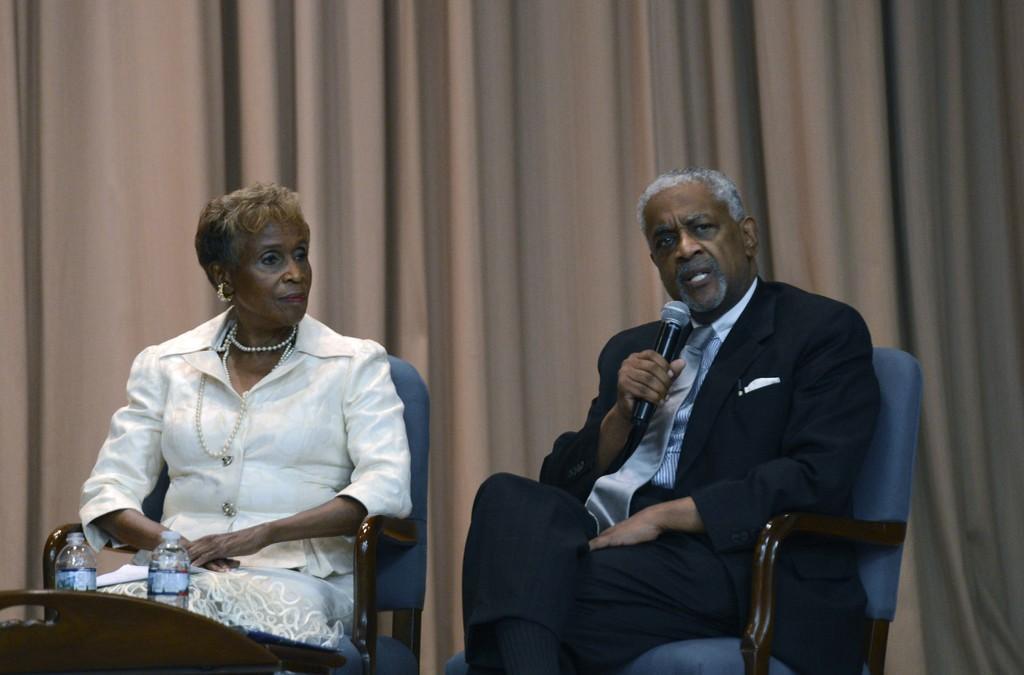Can you describe this image briefly? There are two people in image man and woman siting on chair. On right side there is a man sitting on chair and holding a microphone and opened his mouth for talking. On left side there is a woman sitting on chair in front of a table, on table we can see two water bottles. In background there is a curtain which is in cream color. 